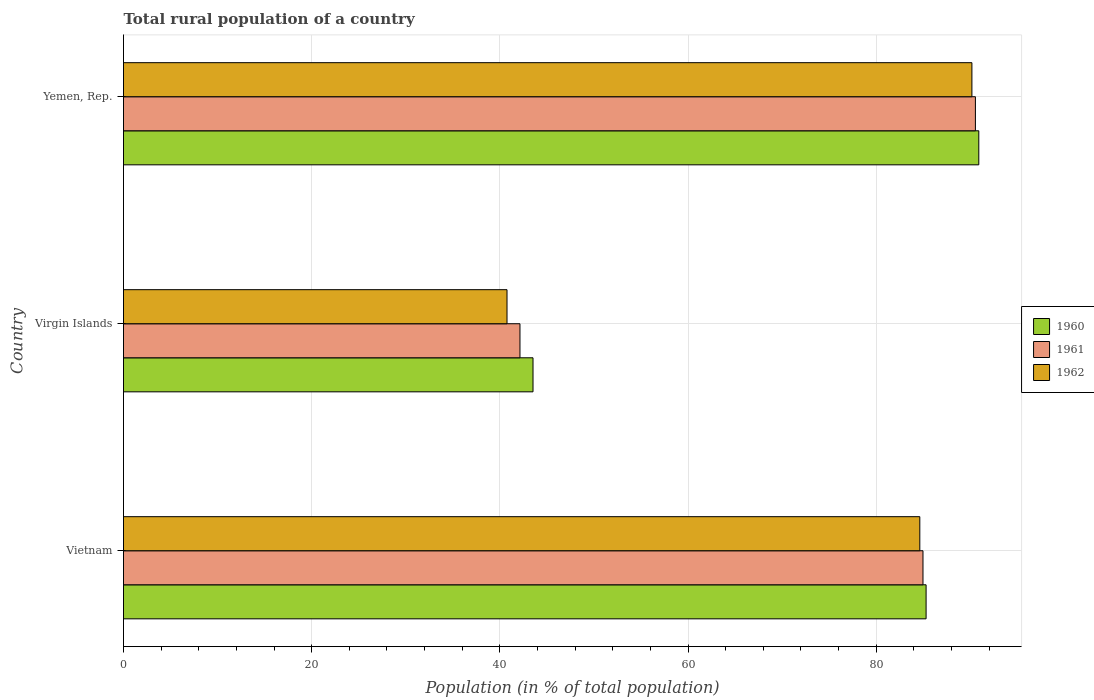How many different coloured bars are there?
Ensure brevity in your answer.  3. Are the number of bars per tick equal to the number of legend labels?
Your answer should be very brief. Yes. Are the number of bars on each tick of the Y-axis equal?
Your response must be concise. Yes. How many bars are there on the 2nd tick from the top?
Provide a succinct answer. 3. What is the label of the 3rd group of bars from the top?
Offer a terse response. Vietnam. In how many cases, is the number of bars for a given country not equal to the number of legend labels?
Your answer should be compact. 0. What is the rural population in 1960 in Yemen, Rep.?
Ensure brevity in your answer.  90.9. Across all countries, what is the maximum rural population in 1960?
Make the answer very short. 90.9. Across all countries, what is the minimum rural population in 1961?
Provide a short and direct response. 42.14. In which country was the rural population in 1960 maximum?
Offer a very short reply. Yemen, Rep. In which country was the rural population in 1960 minimum?
Give a very brief answer. Virgin Islands. What is the total rural population in 1961 in the graph?
Make the answer very short. 217.65. What is the difference between the rural population in 1961 in Vietnam and that in Yemen, Rep.?
Provide a succinct answer. -5.57. What is the difference between the rural population in 1960 in Virgin Islands and the rural population in 1961 in Vietnam?
Keep it short and to the point. -41.45. What is the average rural population in 1962 per country?
Provide a succinct answer. 71.85. What is the difference between the rural population in 1961 and rural population in 1960 in Vietnam?
Offer a very short reply. -0.33. What is the ratio of the rural population in 1961 in Vietnam to that in Yemen, Rep.?
Keep it short and to the point. 0.94. Is the rural population in 1960 in Vietnam less than that in Virgin Islands?
Offer a very short reply. No. What is the difference between the highest and the second highest rural population in 1961?
Make the answer very short. 5.57. What is the difference between the highest and the lowest rural population in 1962?
Your response must be concise. 49.41. Is the sum of the rural population in 1960 in Vietnam and Yemen, Rep. greater than the maximum rural population in 1961 across all countries?
Your response must be concise. Yes. What does the 1st bar from the bottom in Yemen, Rep. represents?
Your response must be concise. 1960. Is it the case that in every country, the sum of the rural population in 1960 and rural population in 1961 is greater than the rural population in 1962?
Your answer should be very brief. Yes. How many bars are there?
Your response must be concise. 9. How many countries are there in the graph?
Make the answer very short. 3. What is the difference between two consecutive major ticks on the X-axis?
Your response must be concise. 20. Does the graph contain grids?
Make the answer very short. Yes. Where does the legend appear in the graph?
Make the answer very short. Center right. How are the legend labels stacked?
Make the answer very short. Vertical. What is the title of the graph?
Your answer should be very brief. Total rural population of a country. What is the label or title of the X-axis?
Offer a very short reply. Population (in % of total population). What is the label or title of the Y-axis?
Ensure brevity in your answer.  Country. What is the Population (in % of total population) of 1960 in Vietnam?
Make the answer very short. 85.3. What is the Population (in % of total population) of 1961 in Vietnam?
Your response must be concise. 84.97. What is the Population (in % of total population) of 1962 in Vietnam?
Provide a succinct answer. 84.63. What is the Population (in % of total population) of 1960 in Virgin Islands?
Ensure brevity in your answer.  43.52. What is the Population (in % of total population) of 1961 in Virgin Islands?
Give a very brief answer. 42.14. What is the Population (in % of total population) in 1962 in Virgin Islands?
Make the answer very short. 40.76. What is the Population (in % of total population) of 1960 in Yemen, Rep.?
Provide a short and direct response. 90.9. What is the Population (in % of total population) in 1961 in Yemen, Rep.?
Your response must be concise. 90.54. What is the Population (in % of total population) of 1962 in Yemen, Rep.?
Offer a terse response. 90.17. Across all countries, what is the maximum Population (in % of total population) of 1960?
Offer a very short reply. 90.9. Across all countries, what is the maximum Population (in % of total population) of 1961?
Provide a succinct answer. 90.54. Across all countries, what is the maximum Population (in % of total population) of 1962?
Keep it short and to the point. 90.17. Across all countries, what is the minimum Population (in % of total population) of 1960?
Ensure brevity in your answer.  43.52. Across all countries, what is the minimum Population (in % of total population) in 1961?
Provide a short and direct response. 42.14. Across all countries, what is the minimum Population (in % of total population) in 1962?
Offer a terse response. 40.76. What is the total Population (in % of total population) in 1960 in the graph?
Ensure brevity in your answer.  219.72. What is the total Population (in % of total population) of 1961 in the graph?
Make the answer very short. 217.65. What is the total Population (in % of total population) of 1962 in the graph?
Your response must be concise. 215.56. What is the difference between the Population (in % of total population) of 1960 in Vietnam and that in Virgin Islands?
Make the answer very short. 41.78. What is the difference between the Population (in % of total population) in 1961 in Vietnam and that in Virgin Islands?
Make the answer very short. 42.83. What is the difference between the Population (in % of total population) in 1962 in Vietnam and that in Virgin Islands?
Your answer should be compact. 43.87. What is the difference between the Population (in % of total population) of 1960 in Vietnam and that in Yemen, Rep.?
Provide a succinct answer. -5.6. What is the difference between the Population (in % of total population) in 1961 in Vietnam and that in Yemen, Rep.?
Provide a succinct answer. -5.57. What is the difference between the Population (in % of total population) in 1962 in Vietnam and that in Yemen, Rep.?
Provide a succinct answer. -5.54. What is the difference between the Population (in % of total population) in 1960 in Virgin Islands and that in Yemen, Rep.?
Your answer should be very brief. -47.38. What is the difference between the Population (in % of total population) of 1961 in Virgin Islands and that in Yemen, Rep.?
Your answer should be compact. -48.41. What is the difference between the Population (in % of total population) of 1962 in Virgin Islands and that in Yemen, Rep.?
Your response must be concise. -49.41. What is the difference between the Population (in % of total population) of 1960 in Vietnam and the Population (in % of total population) of 1961 in Virgin Islands?
Ensure brevity in your answer.  43.16. What is the difference between the Population (in % of total population) in 1960 in Vietnam and the Population (in % of total population) in 1962 in Virgin Islands?
Offer a terse response. 44.54. What is the difference between the Population (in % of total population) of 1961 in Vietnam and the Population (in % of total population) of 1962 in Virgin Islands?
Your response must be concise. 44.21. What is the difference between the Population (in % of total population) in 1960 in Vietnam and the Population (in % of total population) in 1961 in Yemen, Rep.?
Give a very brief answer. -5.24. What is the difference between the Population (in % of total population) in 1960 in Vietnam and the Population (in % of total population) in 1962 in Yemen, Rep.?
Your response must be concise. -4.87. What is the difference between the Population (in % of total population) of 1960 in Virgin Islands and the Population (in % of total population) of 1961 in Yemen, Rep.?
Keep it short and to the point. -47.02. What is the difference between the Population (in % of total population) of 1960 in Virgin Islands and the Population (in % of total population) of 1962 in Yemen, Rep.?
Offer a terse response. -46.65. What is the difference between the Population (in % of total population) of 1961 in Virgin Islands and the Population (in % of total population) of 1962 in Yemen, Rep.?
Your answer should be very brief. -48.03. What is the average Population (in % of total population) of 1960 per country?
Ensure brevity in your answer.  73.24. What is the average Population (in % of total population) in 1961 per country?
Provide a short and direct response. 72.55. What is the average Population (in % of total population) in 1962 per country?
Your response must be concise. 71.85. What is the difference between the Population (in % of total population) in 1960 and Population (in % of total population) in 1961 in Vietnam?
Keep it short and to the point. 0.33. What is the difference between the Population (in % of total population) of 1960 and Population (in % of total population) of 1962 in Vietnam?
Provide a short and direct response. 0.67. What is the difference between the Population (in % of total population) in 1961 and Population (in % of total population) in 1962 in Vietnam?
Provide a short and direct response. 0.34. What is the difference between the Population (in % of total population) in 1960 and Population (in % of total population) in 1961 in Virgin Islands?
Your answer should be very brief. 1.39. What is the difference between the Population (in % of total population) of 1960 and Population (in % of total population) of 1962 in Virgin Islands?
Provide a short and direct response. 2.76. What is the difference between the Population (in % of total population) in 1961 and Population (in % of total population) in 1962 in Virgin Islands?
Ensure brevity in your answer.  1.38. What is the difference between the Population (in % of total population) in 1960 and Population (in % of total population) in 1961 in Yemen, Rep.?
Give a very brief answer. 0.36. What is the difference between the Population (in % of total population) in 1960 and Population (in % of total population) in 1962 in Yemen, Rep.?
Make the answer very short. 0.73. What is the difference between the Population (in % of total population) of 1961 and Population (in % of total population) of 1962 in Yemen, Rep.?
Your answer should be very brief. 0.37. What is the ratio of the Population (in % of total population) of 1960 in Vietnam to that in Virgin Islands?
Keep it short and to the point. 1.96. What is the ratio of the Population (in % of total population) of 1961 in Vietnam to that in Virgin Islands?
Offer a very short reply. 2.02. What is the ratio of the Population (in % of total population) of 1962 in Vietnam to that in Virgin Islands?
Your answer should be compact. 2.08. What is the ratio of the Population (in % of total population) in 1960 in Vietnam to that in Yemen, Rep.?
Provide a succinct answer. 0.94. What is the ratio of the Population (in % of total population) in 1961 in Vietnam to that in Yemen, Rep.?
Your answer should be compact. 0.94. What is the ratio of the Population (in % of total population) in 1962 in Vietnam to that in Yemen, Rep.?
Offer a very short reply. 0.94. What is the ratio of the Population (in % of total population) of 1960 in Virgin Islands to that in Yemen, Rep.?
Ensure brevity in your answer.  0.48. What is the ratio of the Population (in % of total population) of 1961 in Virgin Islands to that in Yemen, Rep.?
Give a very brief answer. 0.47. What is the ratio of the Population (in % of total population) in 1962 in Virgin Islands to that in Yemen, Rep.?
Provide a short and direct response. 0.45. What is the difference between the highest and the second highest Population (in % of total population) of 1961?
Provide a succinct answer. 5.57. What is the difference between the highest and the second highest Population (in % of total population) in 1962?
Give a very brief answer. 5.54. What is the difference between the highest and the lowest Population (in % of total population) of 1960?
Make the answer very short. 47.38. What is the difference between the highest and the lowest Population (in % of total population) in 1961?
Your answer should be very brief. 48.41. What is the difference between the highest and the lowest Population (in % of total population) in 1962?
Your answer should be compact. 49.41. 